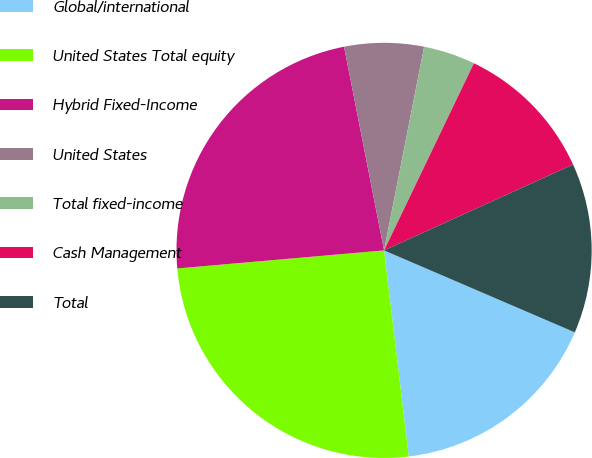<chart> <loc_0><loc_0><loc_500><loc_500><pie_chart><fcel>Global/international<fcel>United States Total equity<fcel>Hybrid Fixed-Income<fcel>United States<fcel>Total fixed-income<fcel>Cash Management<fcel>Total<nl><fcel>16.64%<fcel>25.52%<fcel>23.3%<fcel>6.18%<fcel>4.03%<fcel>11.09%<fcel>13.25%<nl></chart> 